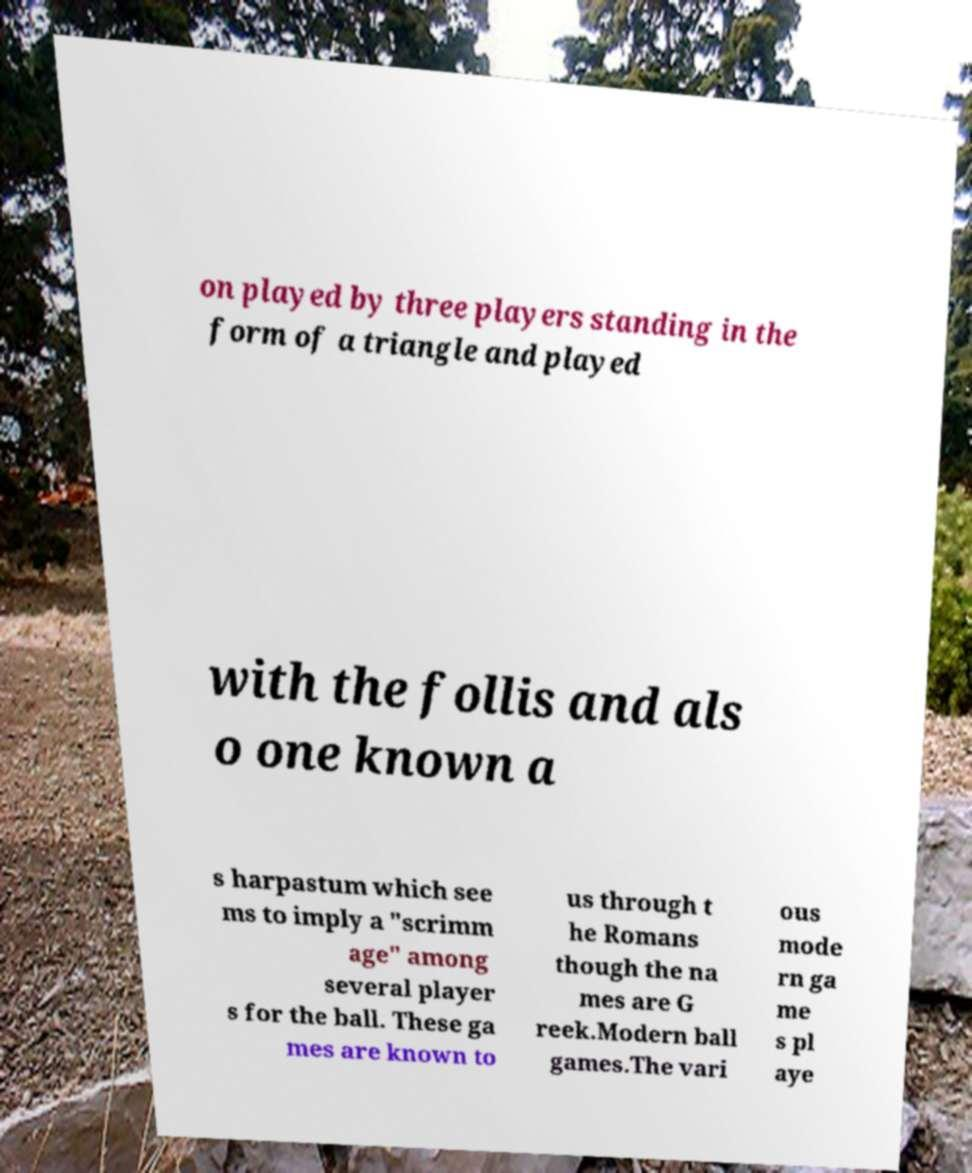Can you read and provide the text displayed in the image?This photo seems to have some interesting text. Can you extract and type it out for me? on played by three players standing in the form of a triangle and played with the follis and als o one known a s harpastum which see ms to imply a "scrimm age" among several player s for the ball. These ga mes are known to us through t he Romans though the na mes are G reek.Modern ball games.The vari ous mode rn ga me s pl aye 